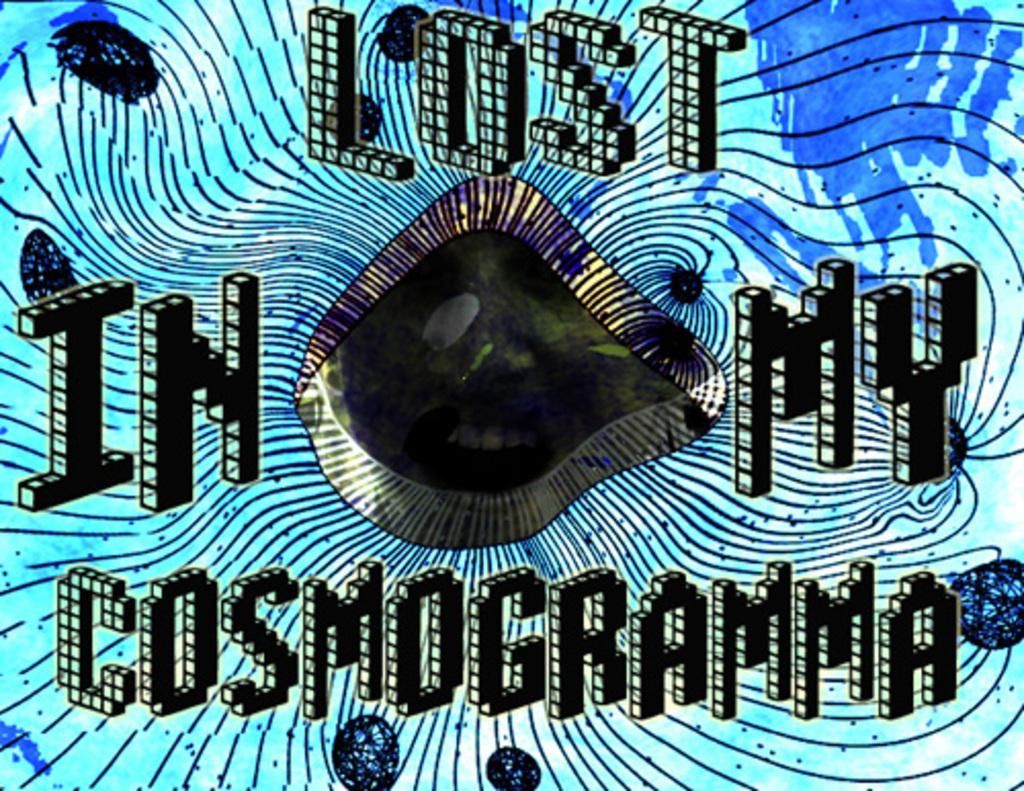<image>
Write a terse but informative summary of the picture. The words Lost In My Cosmogramma are written in a blocky font on a blue background. 